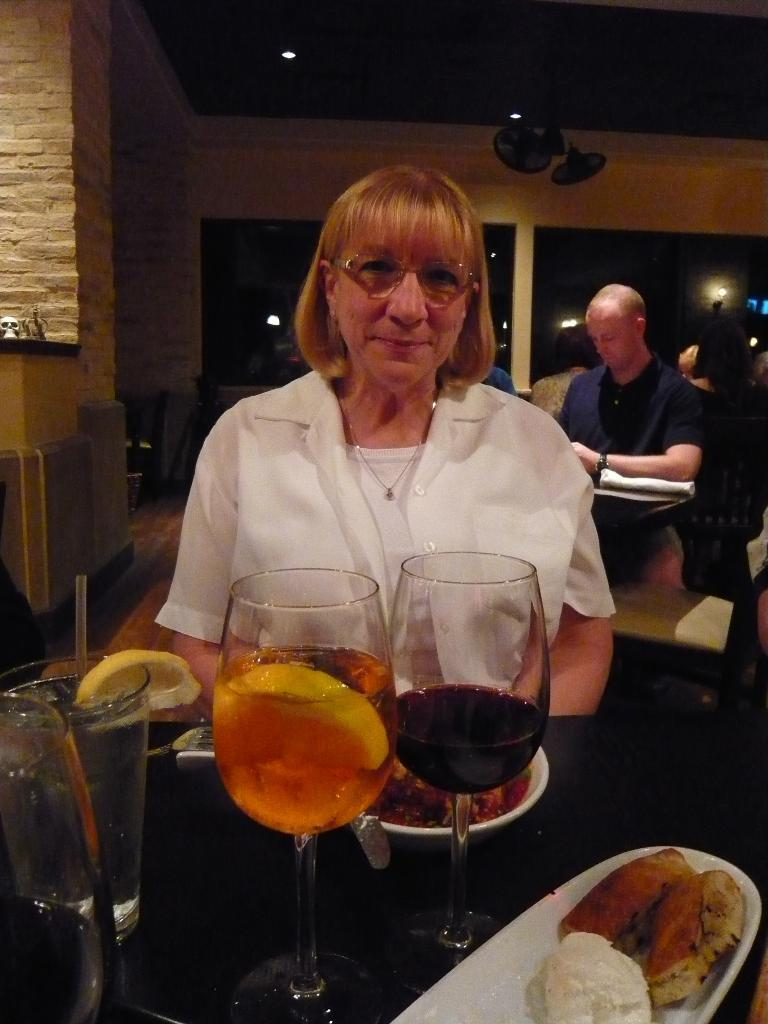Who is in the image? There is a woman in the image. What objects are on the table in the image? Glasses, plates, and food are on the table in the image. What can be seen in the background of the image? There is a wall, persons, another table, windows, and lights visible in the background. What type of appliances are present in the image? Fans are present in the image. What type of crib is visible in the image? There is no crib present in the image. Who is the manager in the image? There is no mention of a manager in the image. 